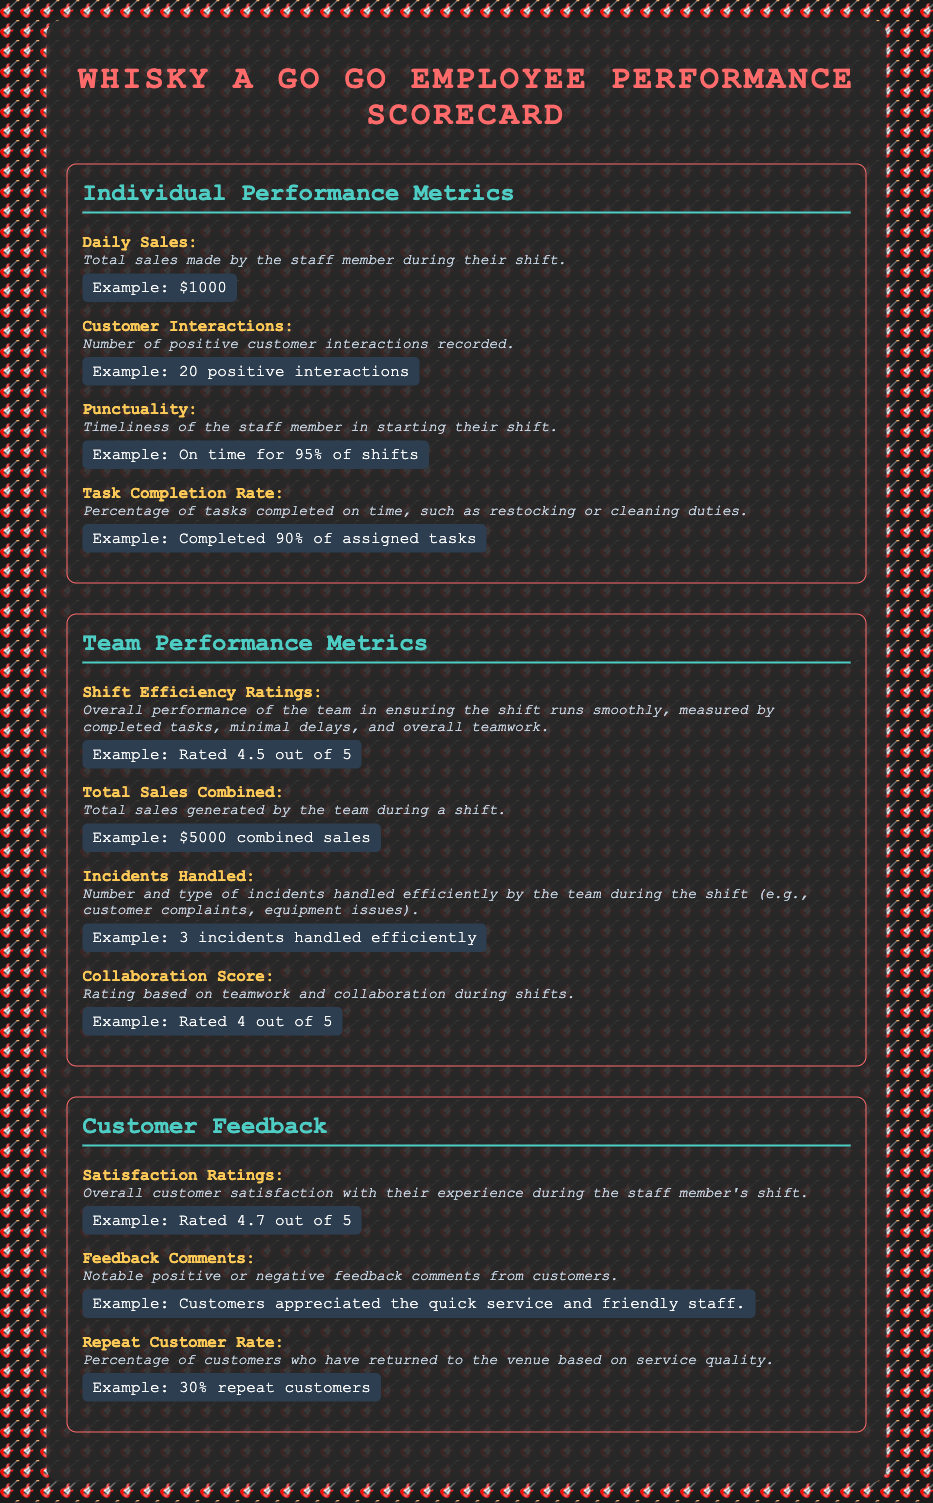What is the score for Shift Efficiency Ratings? The Shift Efficiency Ratings is measured by overall performance of the team, which is rated 4.5 out of 5.
Answer: 4.5 out of 5 What is the Task Completion Rate? The Task Completion Rate is the percentage of tasks completed on time, which is 90%.
Answer: 90% What does the Customer Interactions metric represent? Customer Interactions refers to the number of positive customer interactions recorded by the staff member, which is 20.
Answer: 20 positive interactions What is the total sales generated by the team during a shift? The Total Sales Combined is the total sales generated by the team, which is $5000.
Answer: $5000 What is the Satisfaction Rating from customers? The Satisfaction Ratings measure overall customer satisfaction during the staff member's shift, which is rated 4.7 out of 5.
Answer: 4.7 out of 5 What is the Repeat Customer Rate? The Repeat Customer Rate measures the percentage of customers who have returned to the venue, which is 30%.
Answer: 30% What is the rating for Collaboration Score? The Collaboration Score is a rating based on teamwork and collaboration, which is 4 out of 5.
Answer: 4 out of 5 How many incidents were handled efficiently by the team? The number of incidents handled efficiently is recorded as 3 incidents.
Answer: 3 incidents 